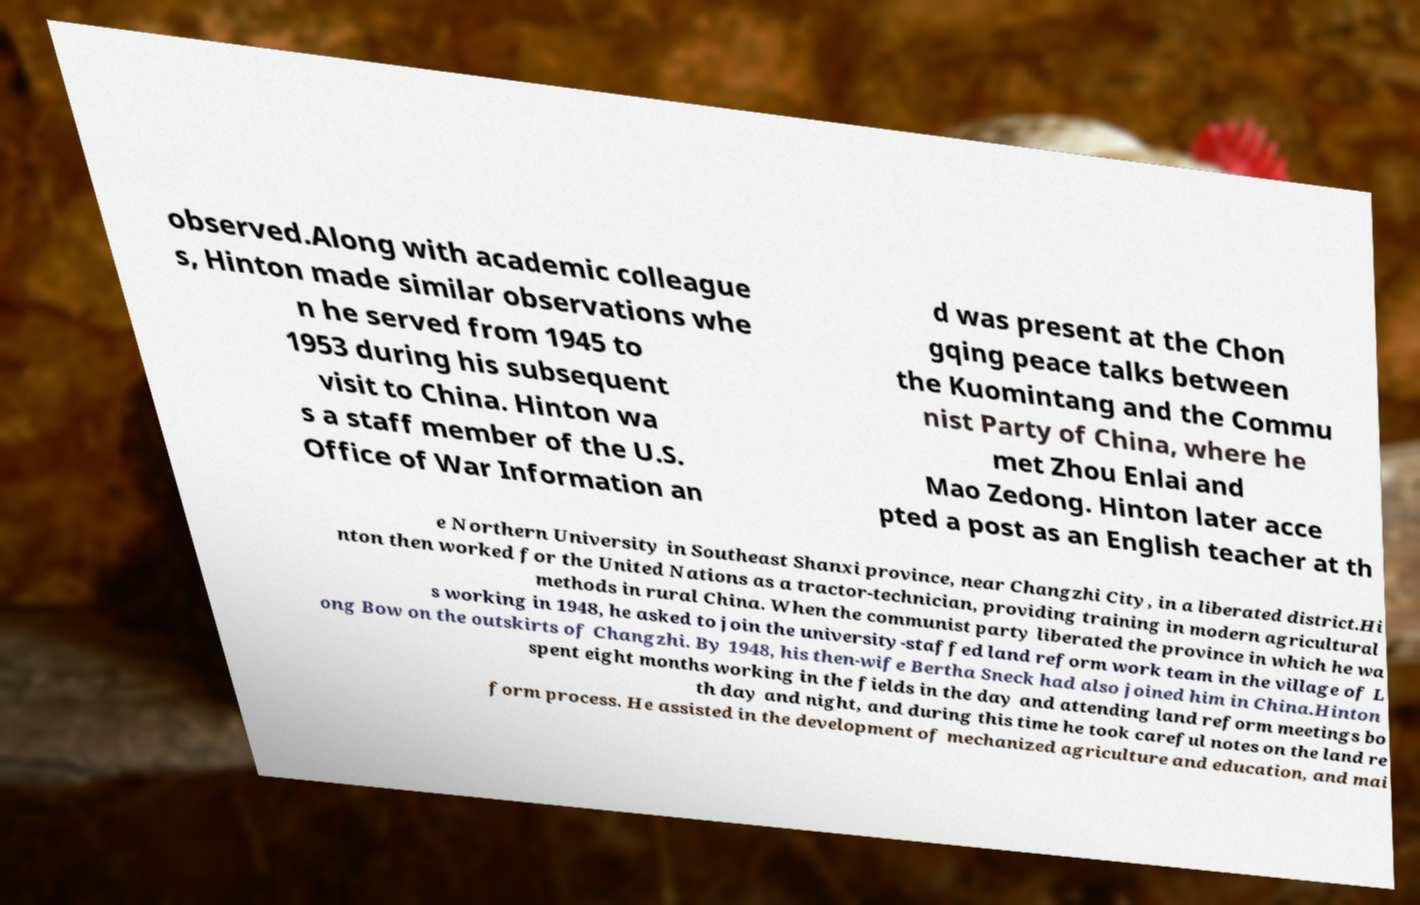For documentation purposes, I need the text within this image transcribed. Could you provide that? observed.Along with academic colleague s, Hinton made similar observations whe n he served from 1945 to 1953 during his subsequent visit to China. Hinton wa s a staff member of the U.S. Office of War Information an d was present at the Chon gqing peace talks between the Kuomintang and the Commu nist Party of China, where he met Zhou Enlai and Mao Zedong. Hinton later acce pted a post as an English teacher at th e Northern University in Southeast Shanxi province, near Changzhi City, in a liberated district.Hi nton then worked for the United Nations as a tractor-technician, providing training in modern agricultural methods in rural China. When the communist party liberated the province in which he wa s working in 1948, he asked to join the university-staffed land reform work team in the village of L ong Bow on the outskirts of Changzhi. By 1948, his then-wife Bertha Sneck had also joined him in China.Hinton spent eight months working in the fields in the day and attending land reform meetings bo th day and night, and during this time he took careful notes on the land re form process. He assisted in the development of mechanized agriculture and education, and mai 